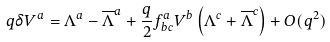<formula> <loc_0><loc_0><loc_500><loc_500>q \delta V ^ { a } = \Lambda ^ { a } - \overline { \Lambda } ^ { a } + \frac { q } { 2 } f ^ { a } _ { b c } V ^ { b } \left ( \Lambda ^ { c } + \overline { \Lambda } ^ { c } \right ) + O ( q ^ { 2 } )</formula> 